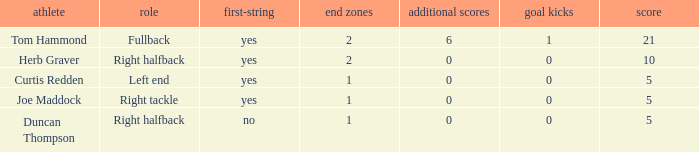Name the fewest touchdowns 1.0. Parse the table in full. {'header': ['athlete', 'role', 'first-string', 'end zones', 'additional scores', 'goal kicks', 'score'], 'rows': [['Tom Hammond', 'Fullback', 'yes', '2', '6', '1', '21'], ['Herb Graver', 'Right halfback', 'yes', '2', '0', '0', '10'], ['Curtis Redden', 'Left end', 'yes', '1', '0', '0', '5'], ['Joe Maddock', 'Right tackle', 'yes', '1', '0', '0', '5'], ['Duncan Thompson', 'Right halfback', 'no', '1', '0', '0', '5']]} 